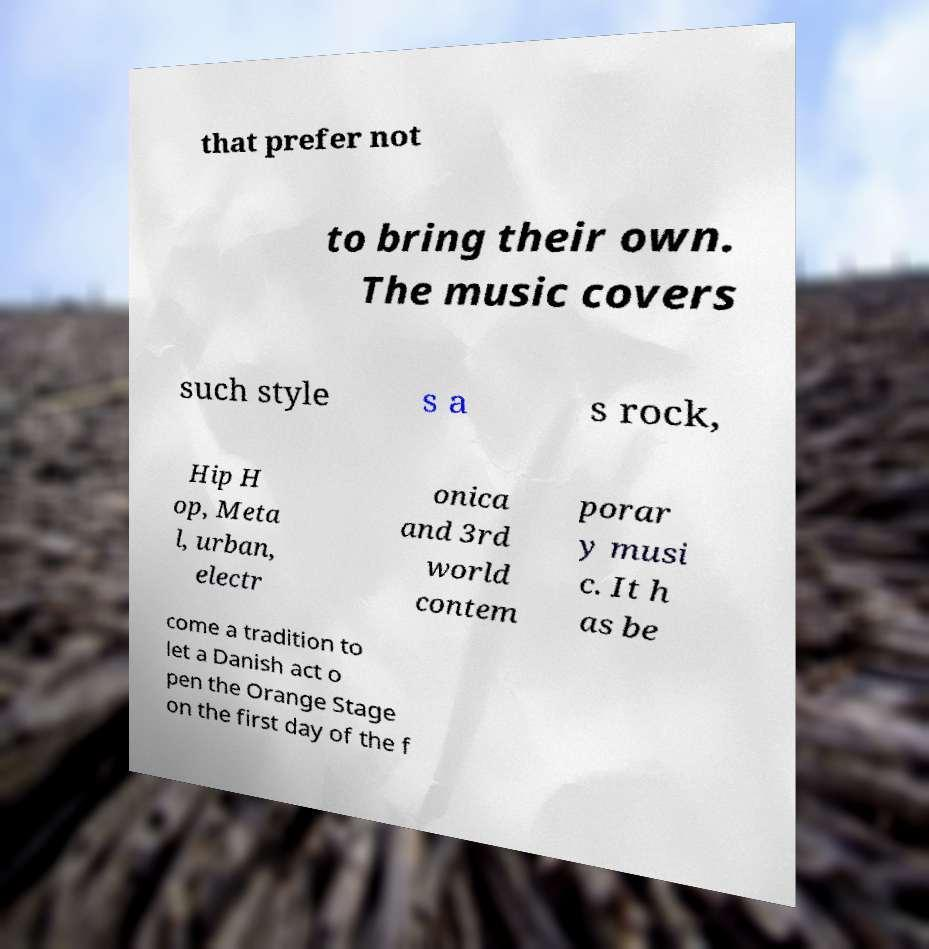Please read and relay the text visible in this image. What does it say? that prefer not to bring their own. The music covers such style s a s rock, Hip H op, Meta l, urban, electr onica and 3rd world contem porar y musi c. It h as be come a tradition to let a Danish act o pen the Orange Stage on the first day of the f 